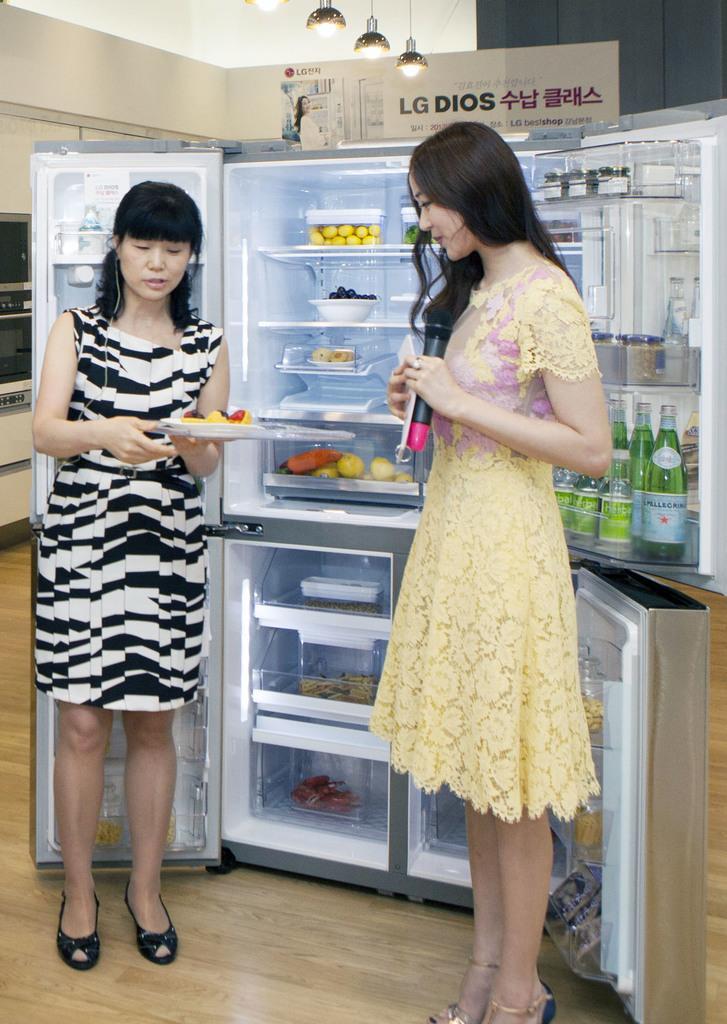In one or two sentences, can you explain what this image depicts? This is the picture of two ladies who are holding some thing and standing in front of the refrigerator in which there are some bottles, fruits and some other things. 